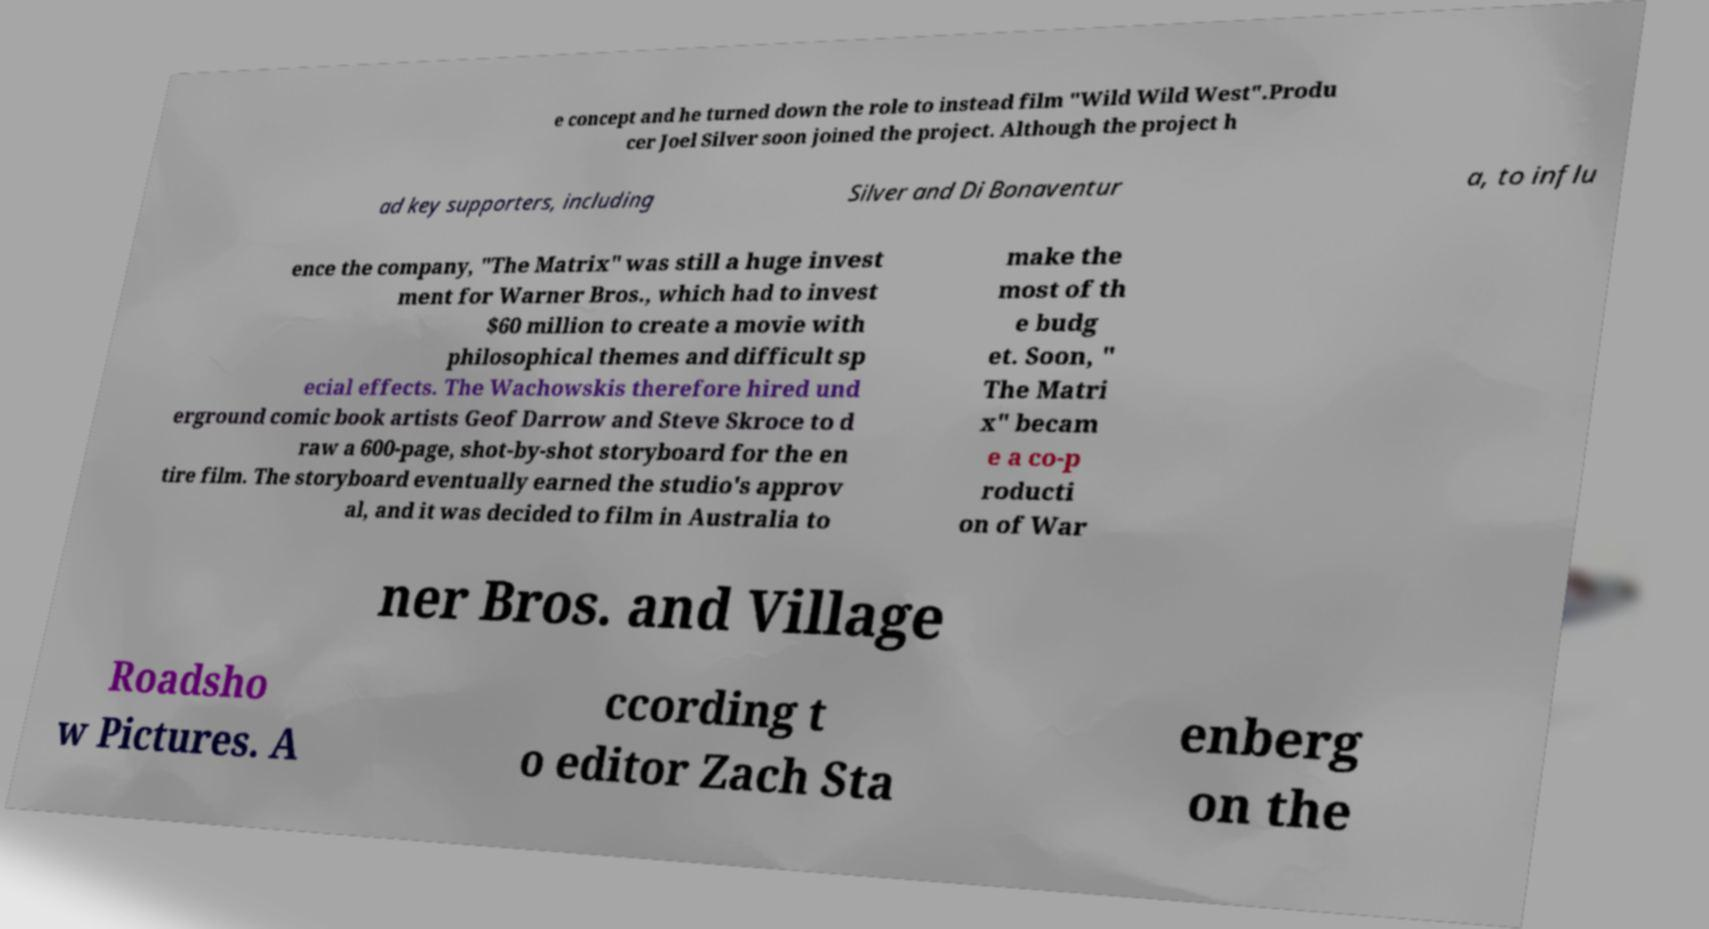I need the written content from this picture converted into text. Can you do that? e concept and he turned down the role to instead film "Wild Wild West".Produ cer Joel Silver soon joined the project. Although the project h ad key supporters, including Silver and Di Bonaventur a, to influ ence the company, "The Matrix" was still a huge invest ment for Warner Bros., which had to invest $60 million to create a movie with philosophical themes and difficult sp ecial effects. The Wachowskis therefore hired und erground comic book artists Geof Darrow and Steve Skroce to d raw a 600-page, shot-by-shot storyboard for the en tire film. The storyboard eventually earned the studio's approv al, and it was decided to film in Australia to make the most of th e budg et. Soon, " The Matri x" becam e a co-p roducti on of War ner Bros. and Village Roadsho w Pictures. A ccording t o editor Zach Sta enberg on the 